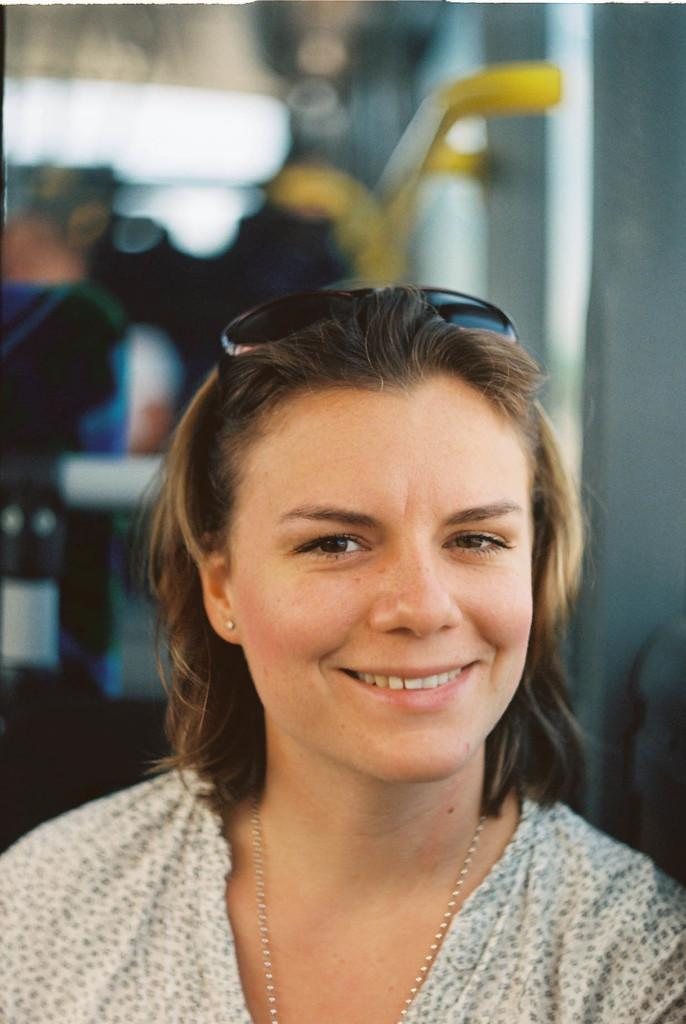Who is present in the image? There is a woman in the image. What is the woman doing in the image? The woman is smiling in the image. Can you describe the background of the image? The background of the image is blurry. What type of box can be seen in the woman's hand in the image? There is no box or hand visible in the image; it only features a woman smiling against a blurry background. 